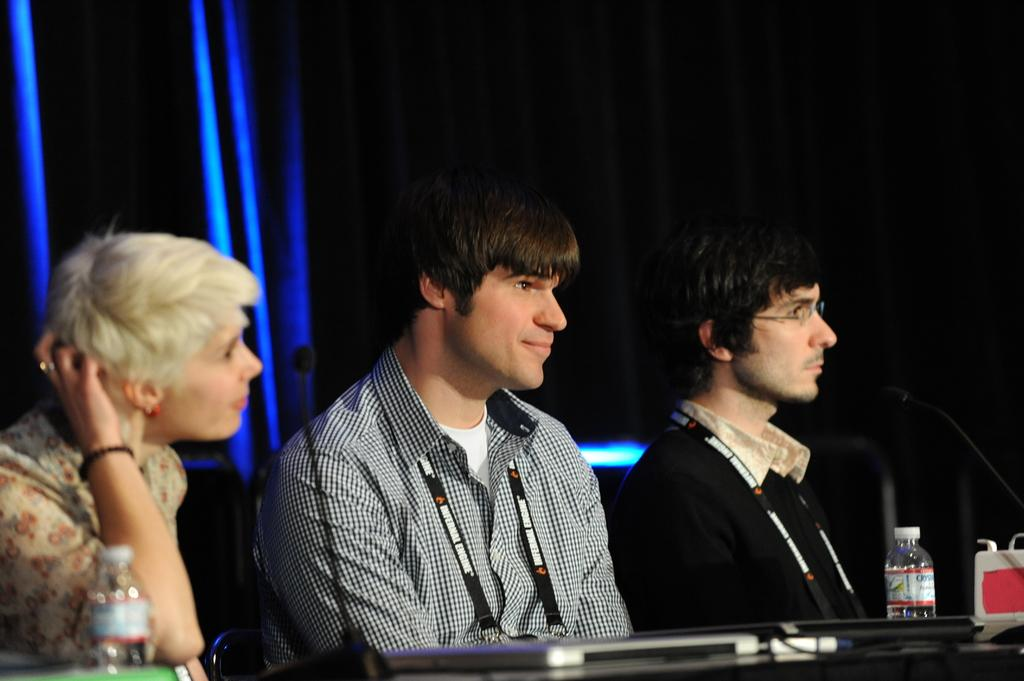How many people are present in the image? There are three people in the image. What are the people doing in the image? The people are sitting near a table. What can be seen on the table in the image? There are bottles on the table, as well as other unspecified things. What type of paper is the uncle holding in the image? There is no uncle present in the image, nor is there any paper visible. 